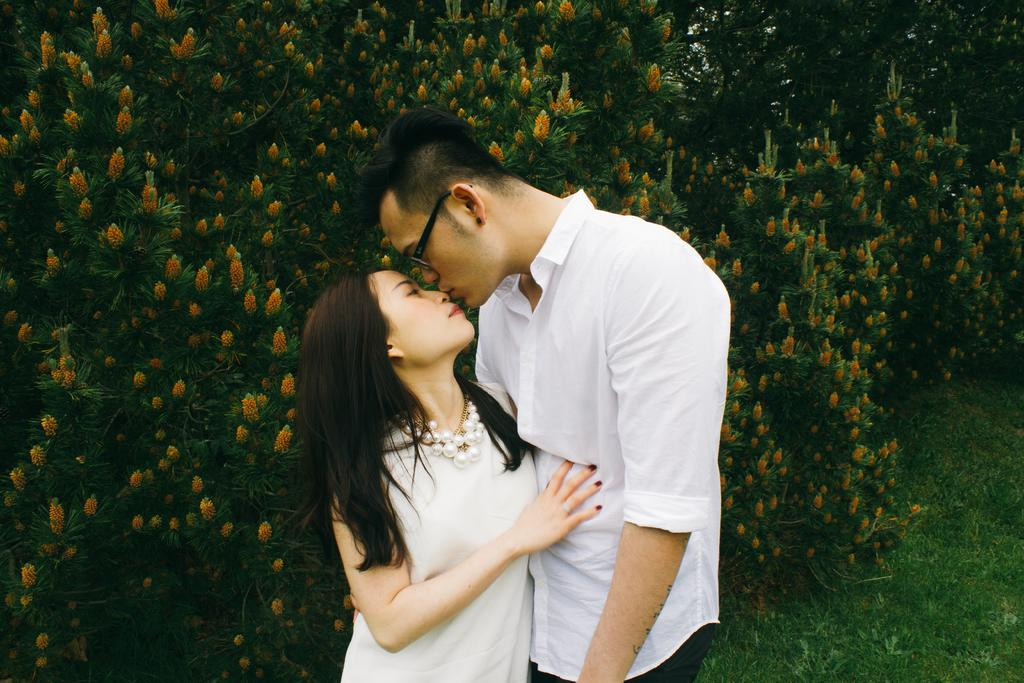Who can be seen in the image? There is a couple standing in the image. What can be seen in the background of the image? There are trees and flowers in the background of the image. What type of vegetation is on the right side of the image? There is grass on the right side of the image. Can you see a tray being carried by the couple in the image? There is no tray visible in the image. Is there a snake slithering through the grass in the image? There is no snake present in the image. 